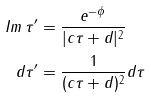<formula> <loc_0><loc_0><loc_500><loc_500>I m \, \tau ^ { \prime } & = \frac { e ^ { - \phi } } { | c \tau + d | ^ { 2 } } \\ d \tau ^ { \prime } & = \frac { 1 } { ( c \tau + d ) ^ { 2 } } d \tau</formula> 